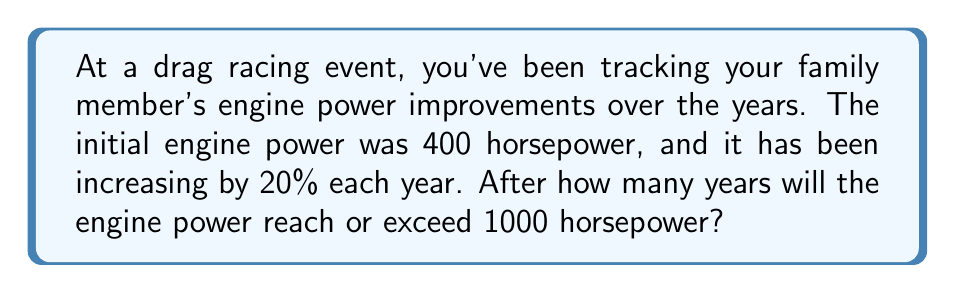Provide a solution to this math problem. Let's approach this step-by-step using logarithms:

1) Let $P$ be the power after $t$ years. We can express this as:

   $P = 400 \cdot (1.2)^t$

2) We want to find $t$ when $P \geq 1000$:

   $1000 \leq 400 \cdot (1.2)^t$

3) Divide both sides by 400:

   $2.5 \leq (1.2)^t$

4) Take the logarithm of both sides. We can use any base, but let's use base 10:

   $\log_{10}(2.5) \leq \log_{10}((1.2)^t)$

5) Use the logarithm property $\log_a(x^n) = n\log_a(x)$:

   $\log_{10}(2.5) \leq t \cdot \log_{10}(1.2)$

6) Solve for $t$:

   $t \geq \frac{\log_{10}(2.5)}{\log_{10}(1.2)}$

7) Calculate this value:

   $t \geq \frac{0.3979}{0.0792} \approx 5.0242$

8) Since we need a whole number of years, and we're looking for when the power will reach or exceed 1000 hp, we round up to the next integer.
Answer: 6 years 